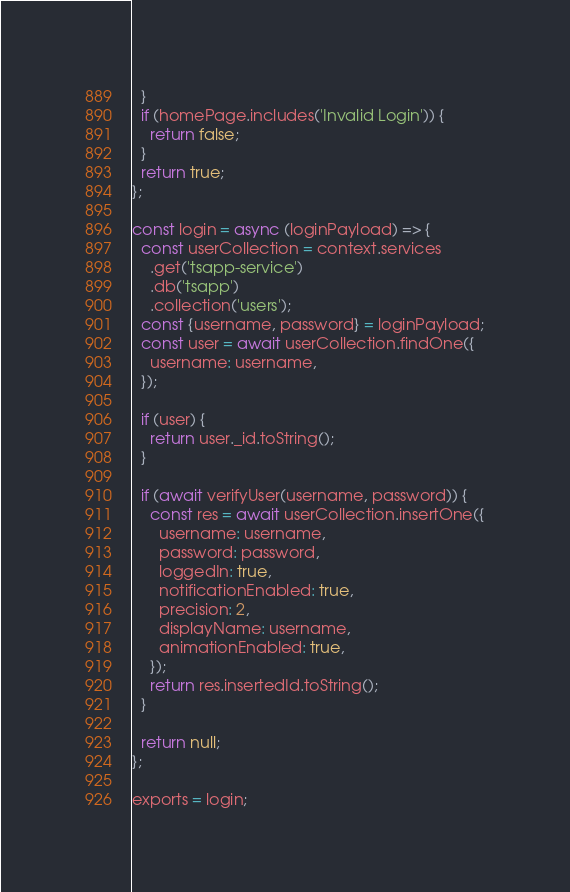<code> <loc_0><loc_0><loc_500><loc_500><_JavaScript_>  }
  if (homePage.includes('Invalid Login')) {
    return false;
  }
  return true;
};

const login = async (loginPayload) => {
  const userCollection = context.services
    .get('tsapp-service')
    .db('tsapp')
    .collection('users');
  const {username, password} = loginPayload;
  const user = await userCollection.findOne({
    username: username,
  });

  if (user) {
    return user._id.toString();
  }

  if (await verifyUser(username, password)) {
    const res = await userCollection.insertOne({
      username: username,
      password: password,
      loggedIn: true,
      notificationEnabled: true,
      precision: 2,
      displayName: username,
      animationEnabled: true,
    });
    return res.insertedId.toString();
  }

  return null;
};

exports = login;
</code> 